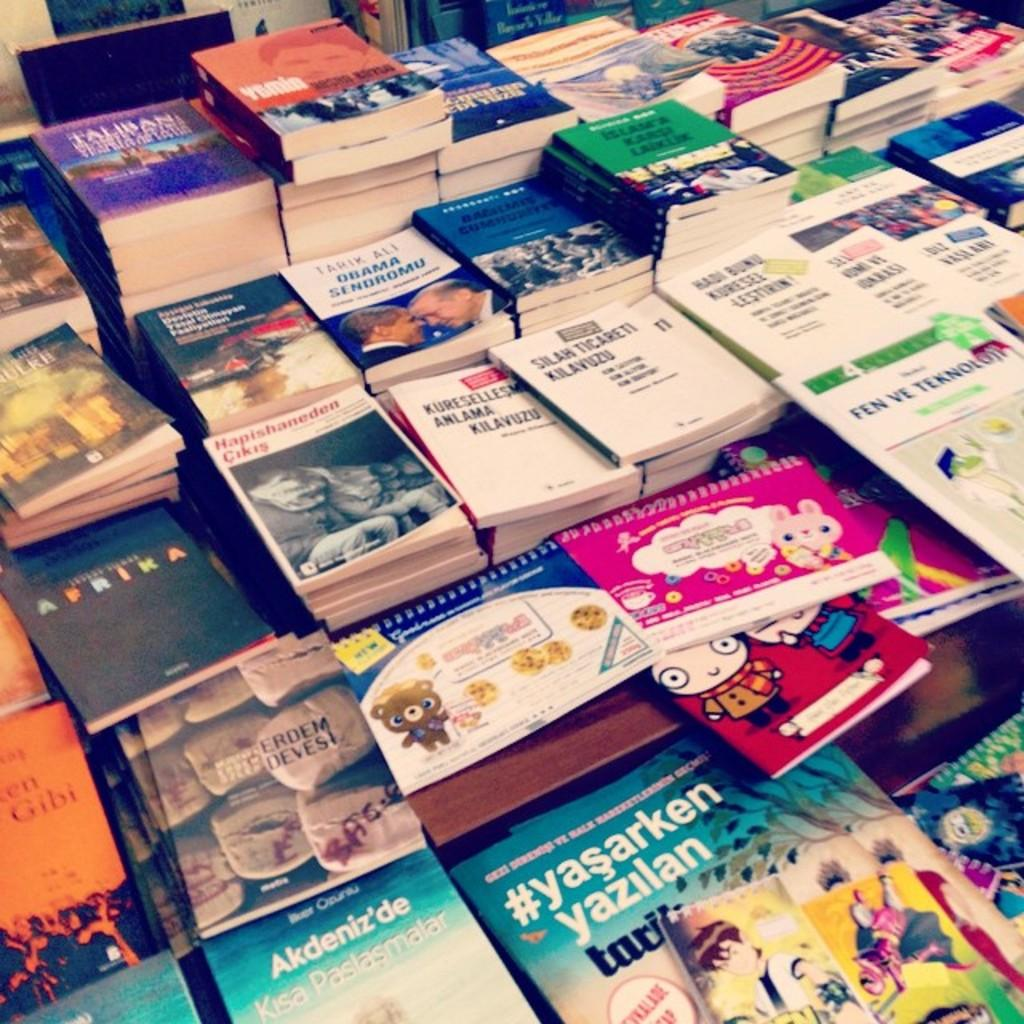<image>
Summarize the visual content of the image. A bunch of books are laid out including one with President Obama on it and another titled Aprika. 